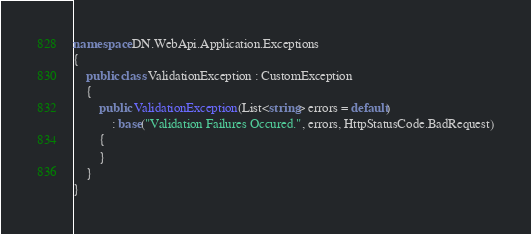<code> <loc_0><loc_0><loc_500><loc_500><_C#_>
namespace DN.WebApi.Application.Exceptions
{
    public class ValidationException : CustomException
    {
        public ValidationException(List<string> errors = default)
            : base("Validation Failures Occured.", errors, HttpStatusCode.BadRequest)
        {
        }
    }
}</code> 